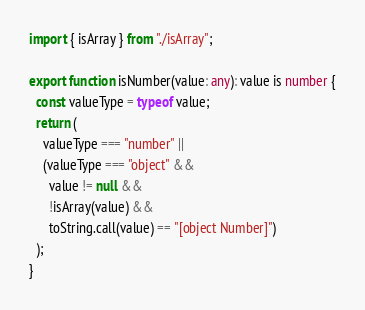Convert code to text. <code><loc_0><loc_0><loc_500><loc_500><_TypeScript_>import { isArray } from "./isArray";

export function isNumber(value: any): value is number {
  const valueType = typeof value;
  return (
    valueType === "number" ||
    (valueType === "object" &&
      value != null &&
      !isArray(value) &&
      toString.call(value) == "[object Number]")
  );
}
</code> 